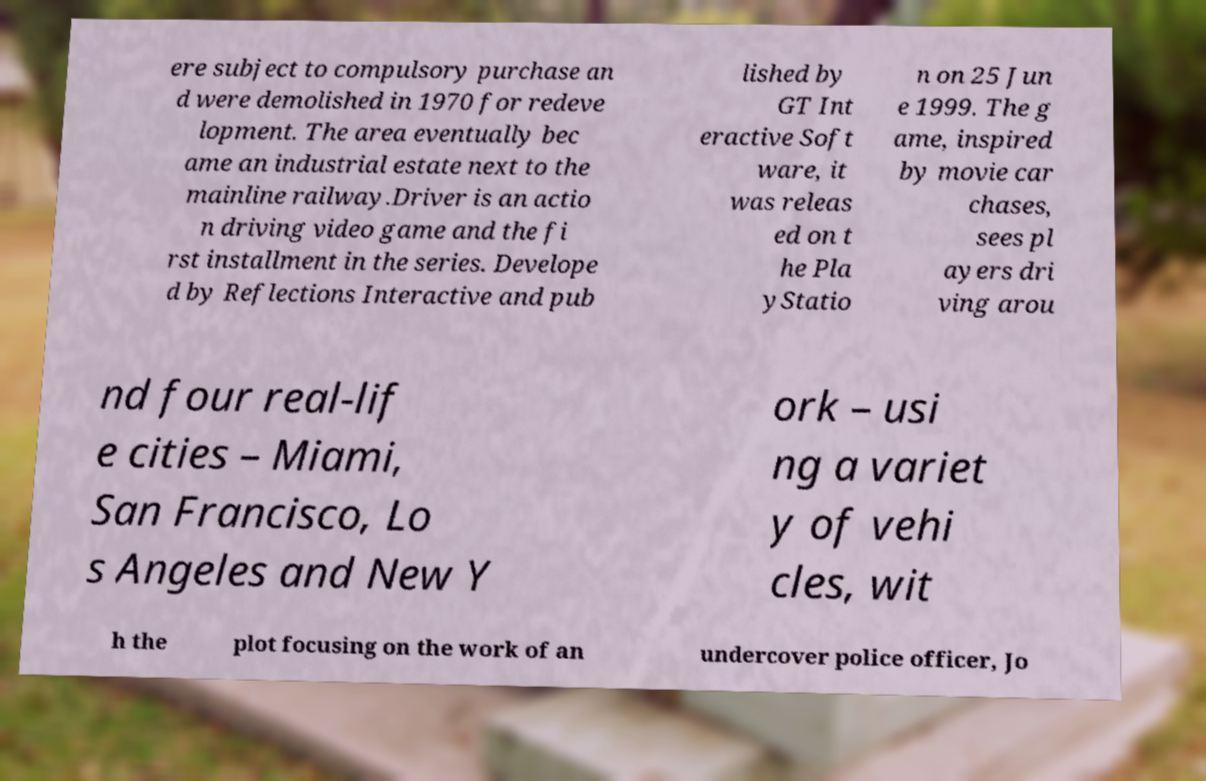Please read and relay the text visible in this image. What does it say? ere subject to compulsory purchase an d were demolished in 1970 for redeve lopment. The area eventually bec ame an industrial estate next to the mainline railway.Driver is an actio n driving video game and the fi rst installment in the series. Develope d by Reflections Interactive and pub lished by GT Int eractive Soft ware, it was releas ed on t he Pla yStatio n on 25 Jun e 1999. The g ame, inspired by movie car chases, sees pl ayers dri ving arou nd four real-lif e cities – Miami, San Francisco, Lo s Angeles and New Y ork – usi ng a variet y of vehi cles, wit h the plot focusing on the work of an undercover police officer, Jo 